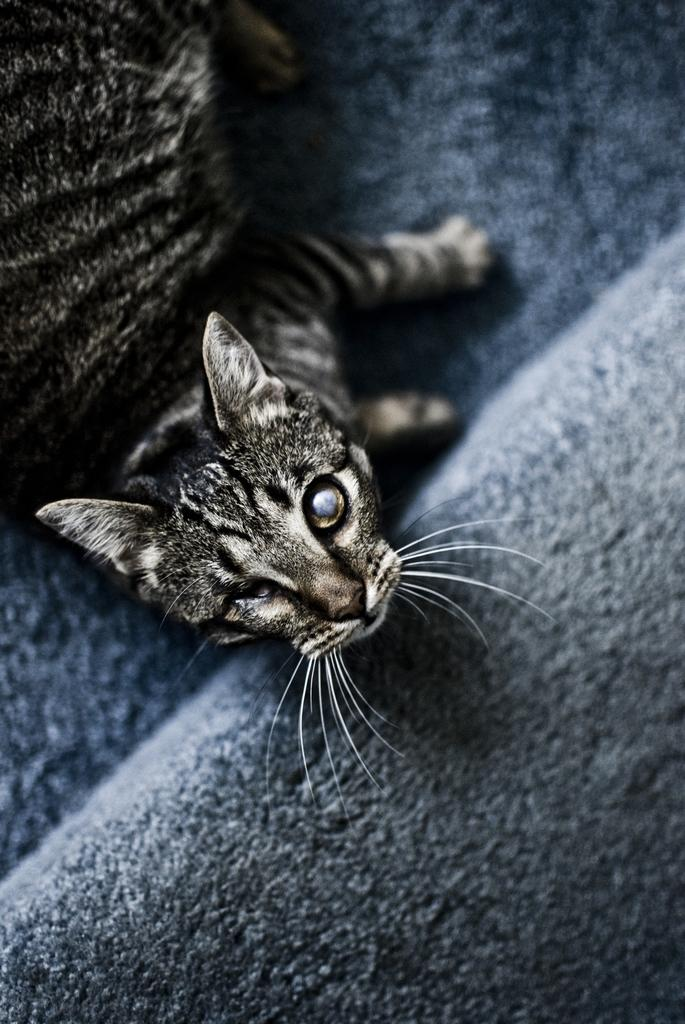What type of animal is in the image? There is a cat in the image. Where is the cat located? The cat is lying on a sofa. What color is the sofa? The sofa is blue in color. What type of grass is growing on the business in the image? There is no grass or business present in the image; it features a cat lying on a blue sofa. 